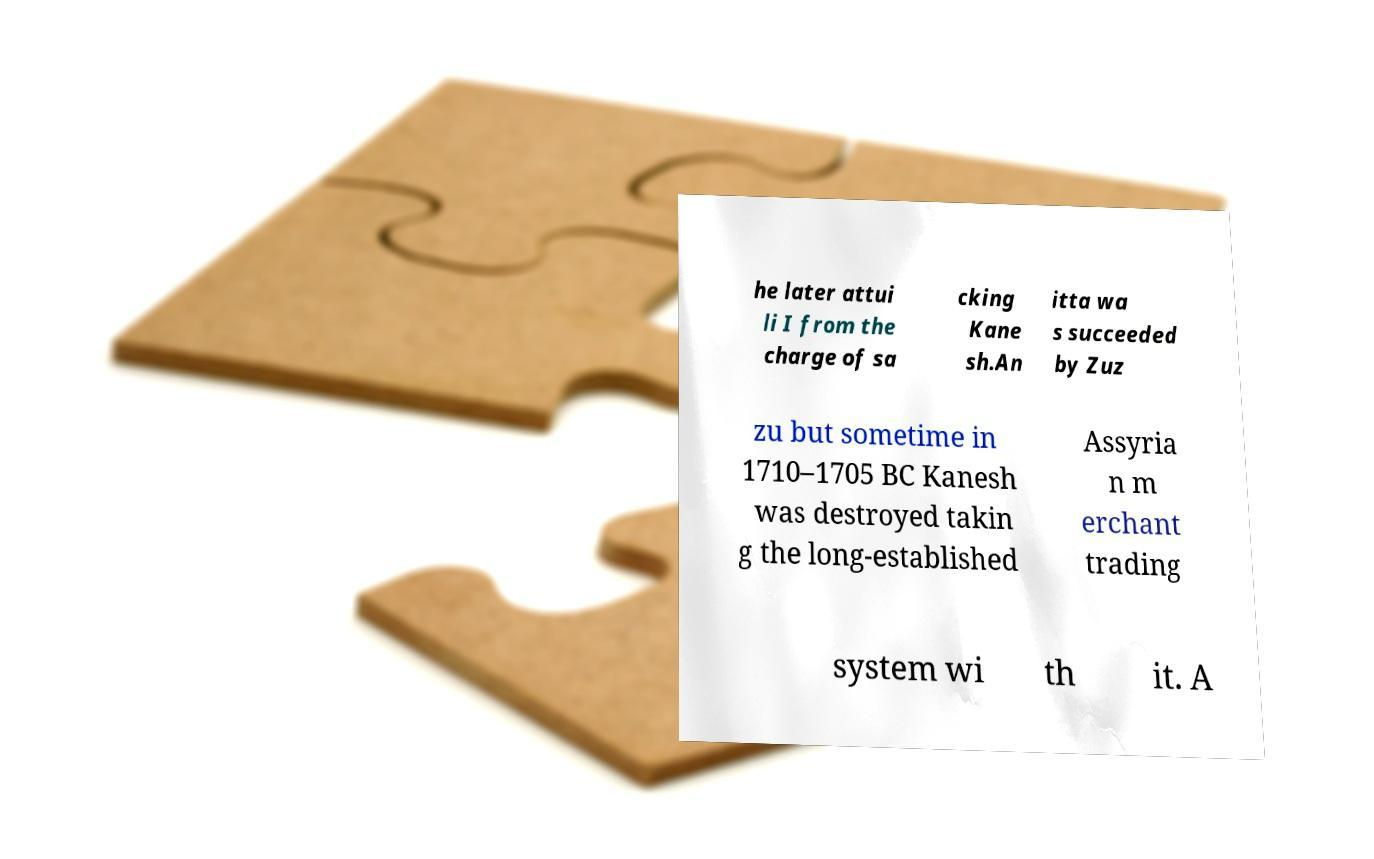Can you read and provide the text displayed in the image?This photo seems to have some interesting text. Can you extract and type it out for me? he later attui li I from the charge of sa cking Kane sh.An itta wa s succeeded by Zuz zu but sometime in 1710–1705 BC Kanesh was destroyed takin g the long-established Assyria n m erchant trading system wi th it. A 